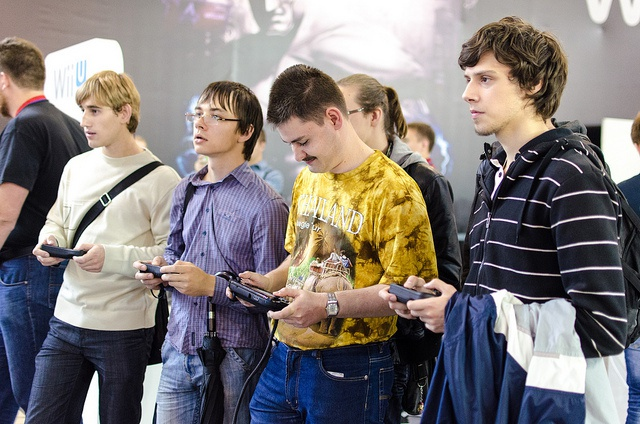Describe the objects in this image and their specific colors. I can see people in gray, black, tan, navy, and khaki tones, people in gray, black, lightgray, and tan tones, people in gray, black, ivory, darkgray, and lightgray tones, people in gray, black, and darkgray tones, and people in gray, black, navy, and tan tones in this image. 